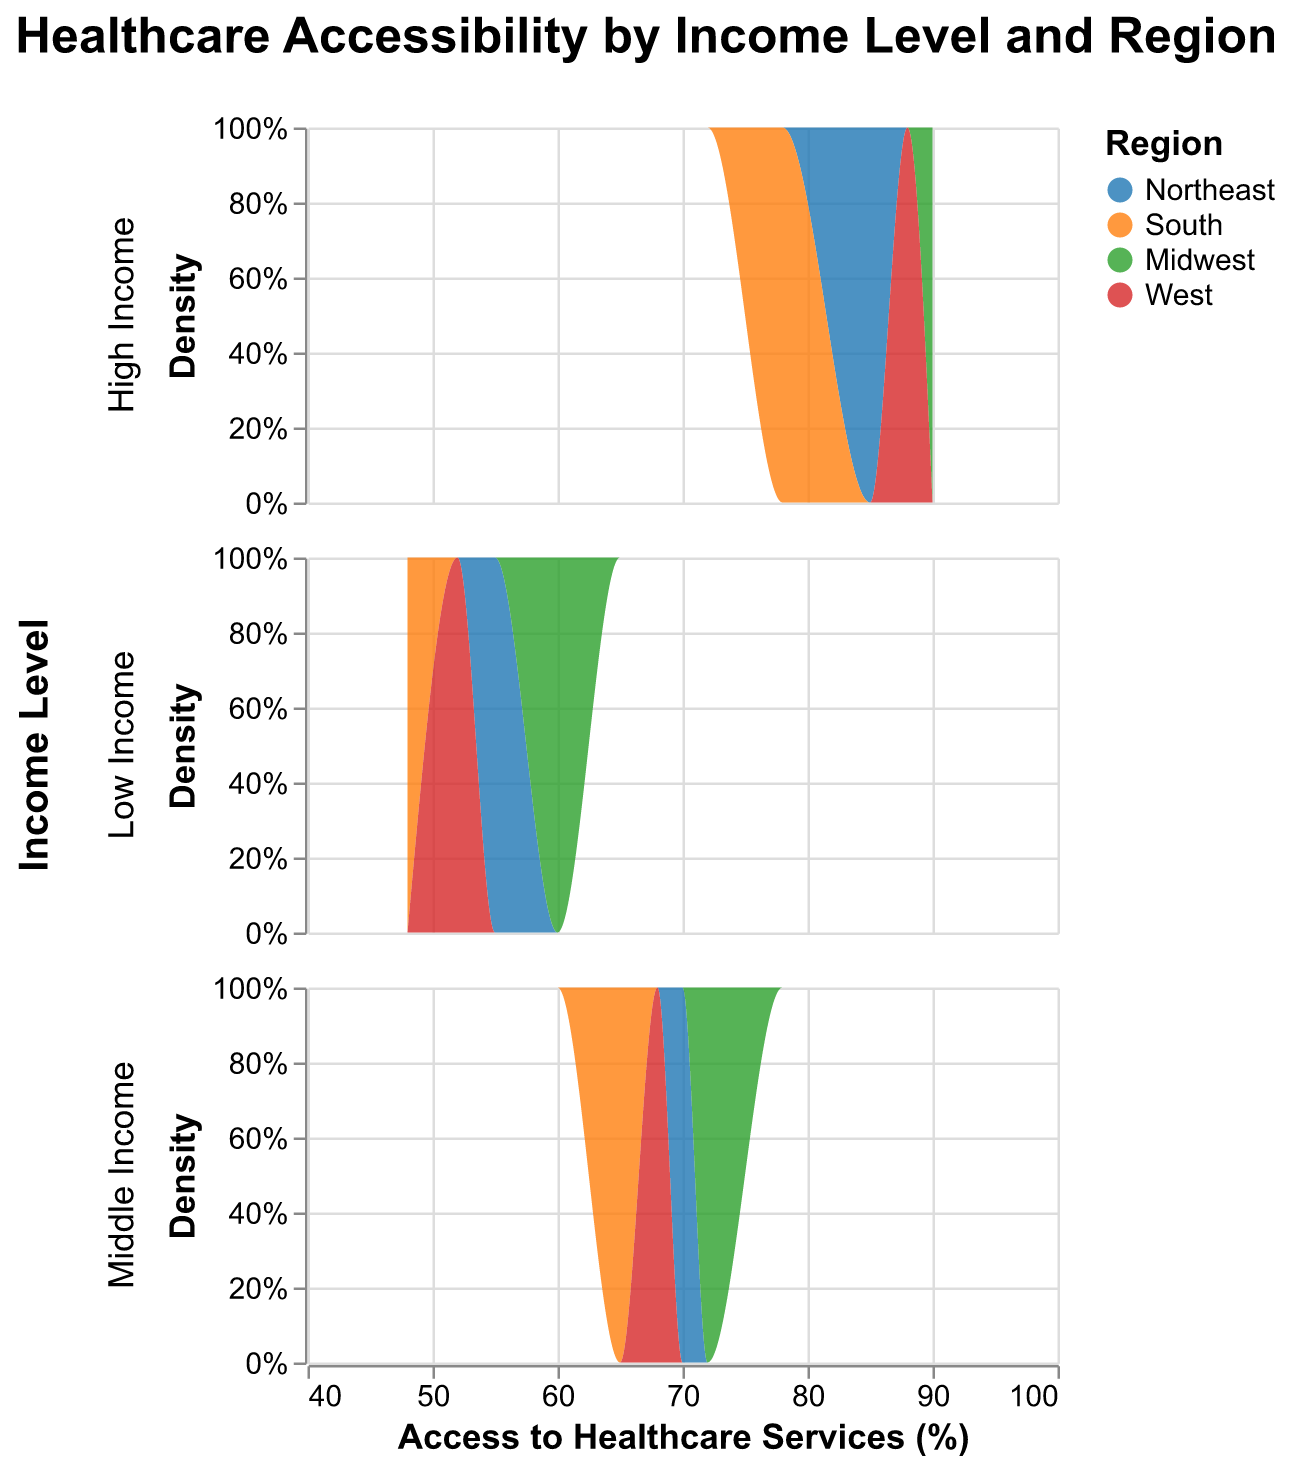What is the title of the figure? The title of the figure is usually found at the top of the chart and helps to summarize what the chart is about. In this case, the title "Healthcare Accessibility by Income Level and Region" is prominently displayed.
Answer: Healthcare Accessibility by Income Level and Region Which region is represented by the color blue? In the legend of the chart, different colors represent different regions. By examining the legend, we can see that the color blue represents the Northeast region.
Answer: Northeast How many income levels are there in the figure? The figure uses facets to separate the data into different rows based on the "Income Level" field. By counting these rows, we can determine the number of income levels. There are three rows: "Low Income", "Middle Income", and "High Income".
Answer: Three Which income level generally has the highest access to healthcare services? To determine this, you'll need to look at the x-axis range for each income level row and see which has the highest access values. High Income generally has the highest access with values around 85-90%.
Answer: High Income Which region has the lowest access to healthcare services for low-income groups? By comparing the density distributions for each region within the "Low Income" row, we can see that the South region has the lowest access values indicated by the orange color and a value of 48%.
Answer: South Comparing middle-income and low-income groups in the Midwest region, which has better access to healthcare services? Locate the "Midwest" distributions within "Low Income" and "Middle Income" rows. The middle-income group has access of 72%, which is higher compared to the low-income group's access of 60%.
Answer: Middle Income What is the range of access to healthcare services for high-income groups across all regions? Examine the x-axis within the "High Income" row and observe the distribution endpoints for all regions. The range lies between 78% and 90%.
Answer: 78% to 90% Which region, overall, seems to consistently have high access to healthcare services across different income levels? By observing the stacked density plots for each row, the "Northeast" region (in blue) consistently has high percentages of access across low, middle, and high-income levels, ranging from 55% to 85%.
Answer: Northeast What is the approximate density peak for middle-income groups in the South region? Focus on the "Middle Income" row and find the density peak indicated by the height of the orange area for the South region. The peak is around 65%.
Answer: 65% Which ethnicity has the highest access to healthcare services in the high-income group? In the "High Income" row, look at each ethnicity's distribution to find the highest access value. The Midwest region, which represents Hispanic ethnicity, has the highest access at 90%.
Answer: Hispanic 